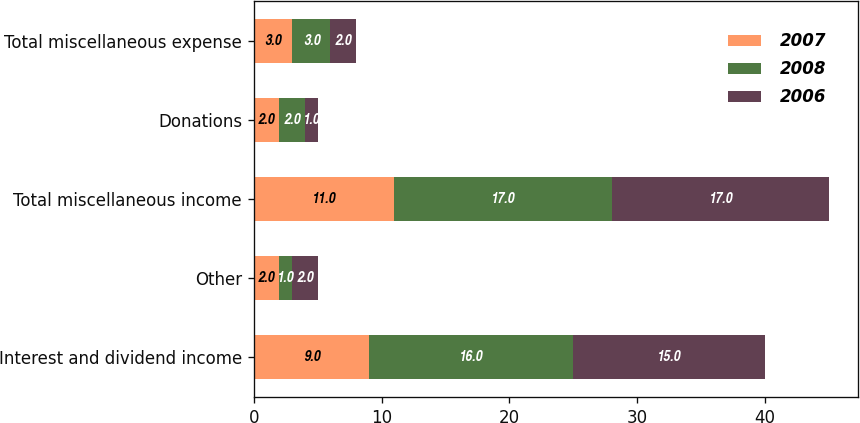<chart> <loc_0><loc_0><loc_500><loc_500><stacked_bar_chart><ecel><fcel>Interest and dividend income<fcel>Other<fcel>Total miscellaneous income<fcel>Donations<fcel>Total miscellaneous expense<nl><fcel>2007<fcel>9<fcel>2<fcel>11<fcel>2<fcel>3<nl><fcel>2008<fcel>16<fcel>1<fcel>17<fcel>2<fcel>3<nl><fcel>2006<fcel>15<fcel>2<fcel>17<fcel>1<fcel>2<nl></chart> 